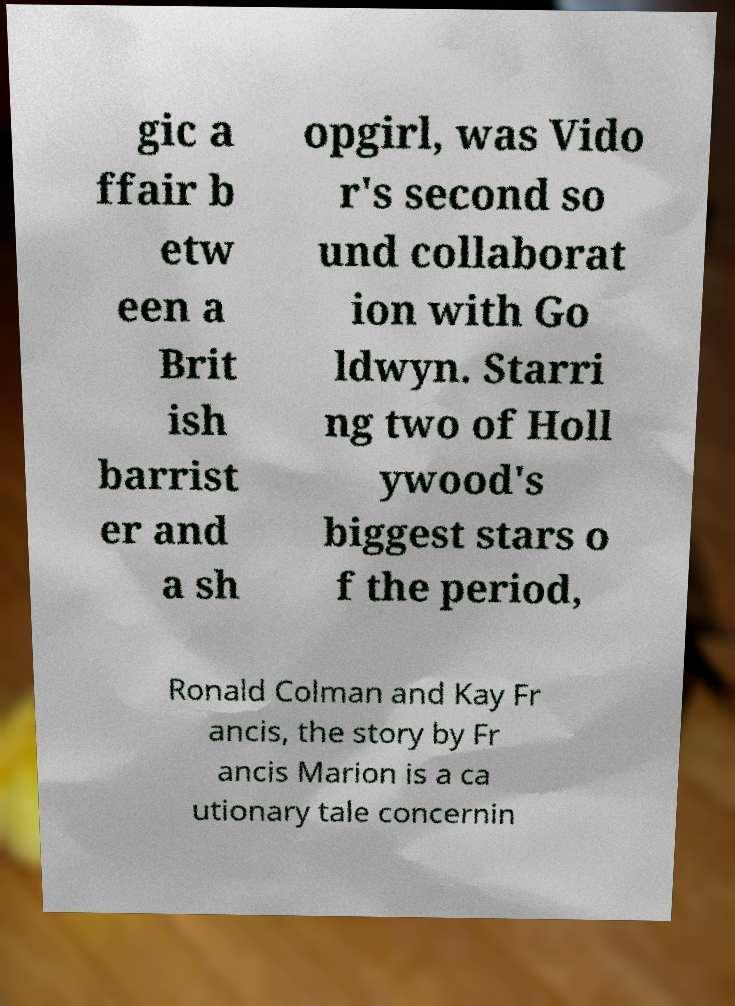Can you read and provide the text displayed in the image?This photo seems to have some interesting text. Can you extract and type it out for me? gic a ffair b etw een a Brit ish barrist er and a sh opgirl, was Vido r's second so und collaborat ion with Go ldwyn. Starri ng two of Holl ywood's biggest stars o f the period, Ronald Colman and Kay Fr ancis, the story by Fr ancis Marion is a ca utionary tale concernin 